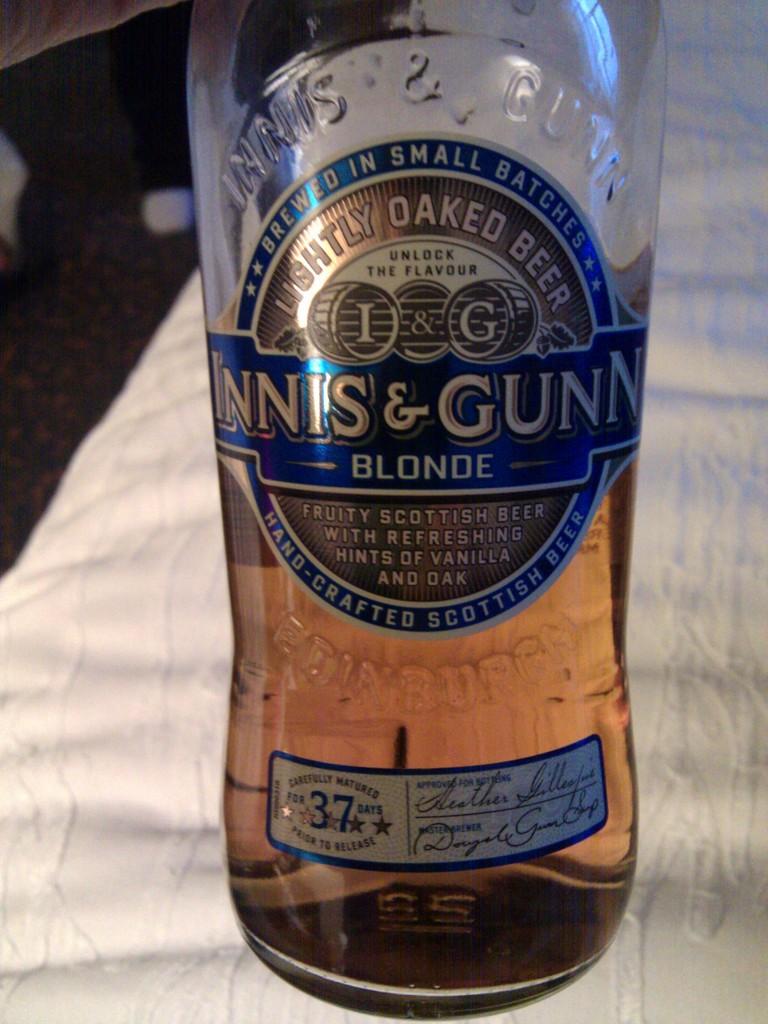What size of batches is this brewed in?
Offer a very short reply. Small. What is the brand name?
Offer a terse response. Innis & gunn. 